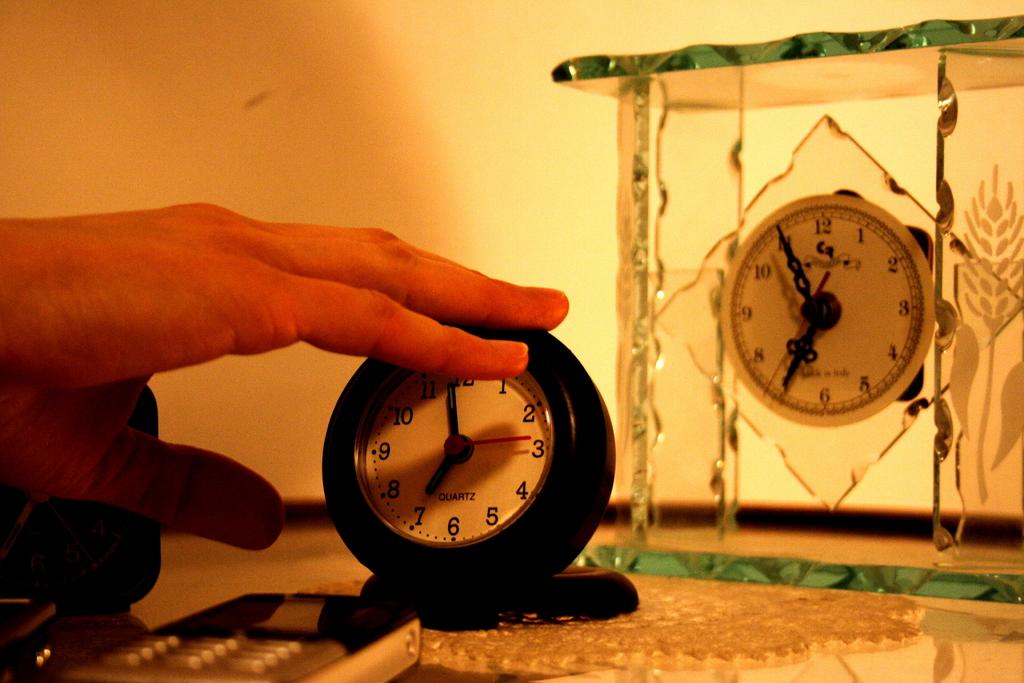<image>
Write a terse but informative summary of the picture. Person touching a clock that has the word QUARTZ on the face. 